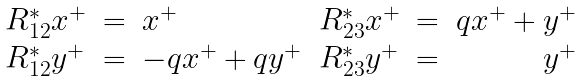<formula> <loc_0><loc_0><loc_500><loc_500>\begin{array} { l l l l l r } R _ { 1 2 } ^ { * } x ^ { + } & = & x ^ { + } & R _ { 2 3 } ^ { * } x ^ { + } & = & q x ^ { + } + y ^ { + } \\ R _ { 1 2 } ^ { * } y ^ { + } & = & - q x ^ { + } + q y ^ { + } & R _ { 2 3 } ^ { * } y ^ { + } & = & y ^ { + } \end{array}</formula> 